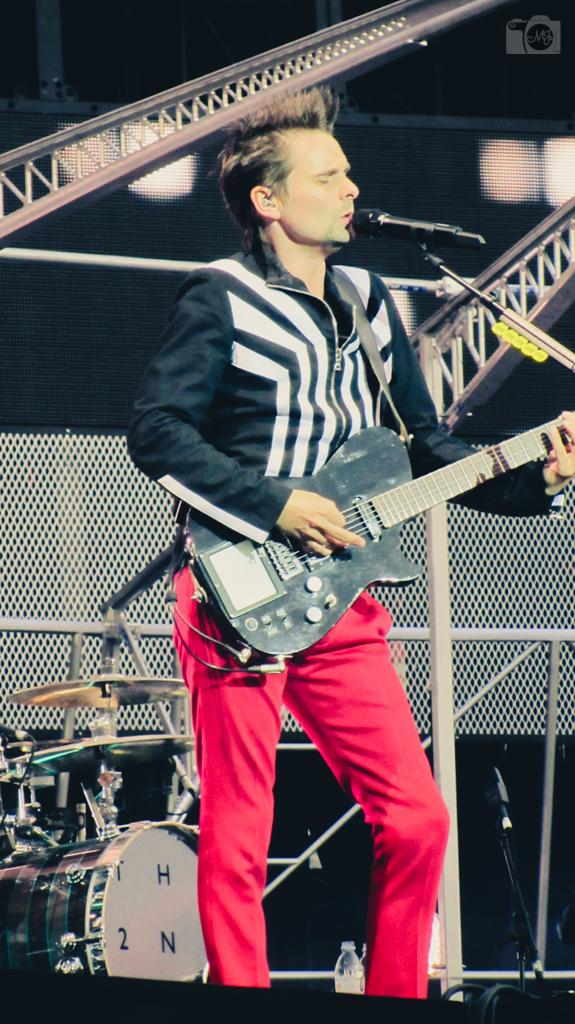What is the man in the image doing? The man is playing the guitar and singing. What instrument is the man holding? The man is holding a guitar. What object is in front of the man? There is a microphone in front of the man. What other musical instrument can be seen in the image? There is a drum set behind the man. How does the turkey contribute to the music in the image? There is no turkey present in the image, so it cannot contribute to the music. 